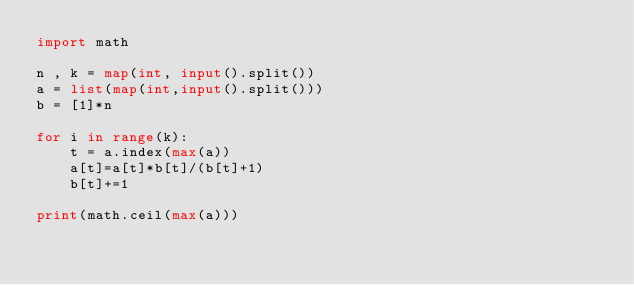<code> <loc_0><loc_0><loc_500><loc_500><_Python_>import math

n , k = map(int, input().split())
a = list(map(int,input().split()))
b = [1]*n

for i in range(k):
    t = a.index(max(a))
    a[t]=a[t]*b[t]/(b[t]+1)
    b[t]+=1

print(math.ceil(max(a)))
</code> 